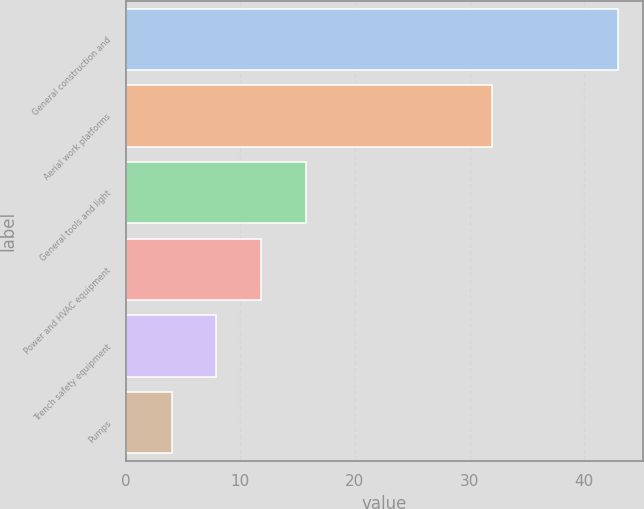Convert chart to OTSL. <chart><loc_0><loc_0><loc_500><loc_500><bar_chart><fcel>General construction and<fcel>Aerial work platforms<fcel>General tools and light<fcel>Power and HVAC equipment<fcel>Trench safety equipment<fcel>Pumps<nl><fcel>43<fcel>32<fcel>15.7<fcel>11.8<fcel>7.9<fcel>4<nl></chart> 